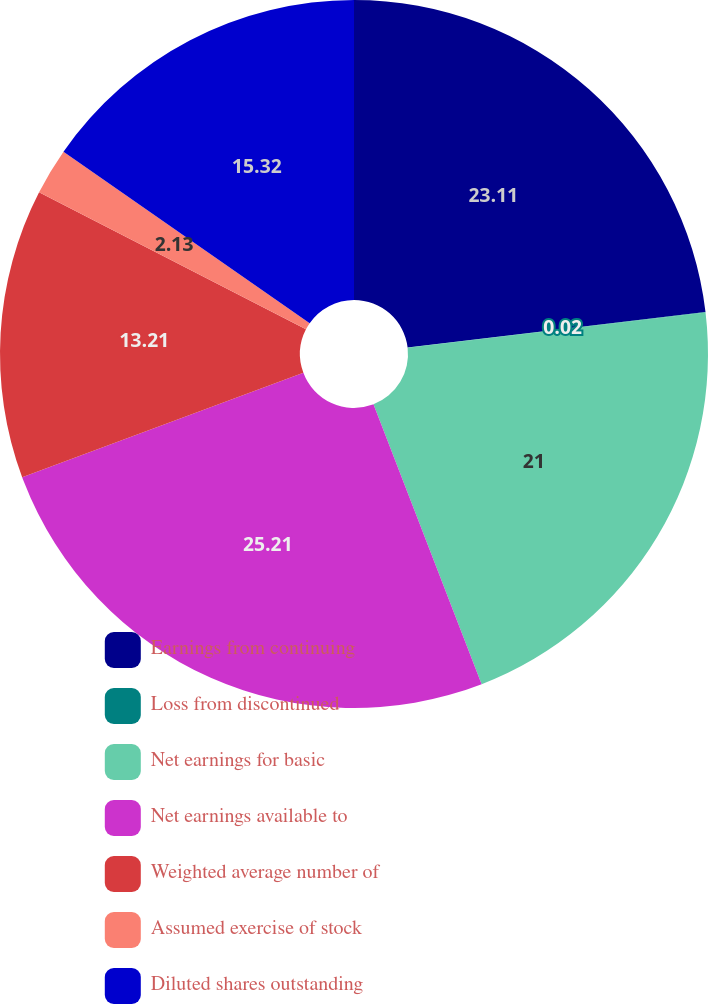<chart> <loc_0><loc_0><loc_500><loc_500><pie_chart><fcel>Earnings from continuing<fcel>Loss from discontinued<fcel>Net earnings for basic<fcel>Net earnings available to<fcel>Weighted average number of<fcel>Assumed exercise of stock<fcel>Diluted shares outstanding<nl><fcel>23.11%<fcel>0.02%<fcel>21.0%<fcel>25.21%<fcel>13.21%<fcel>2.13%<fcel>15.32%<nl></chart> 